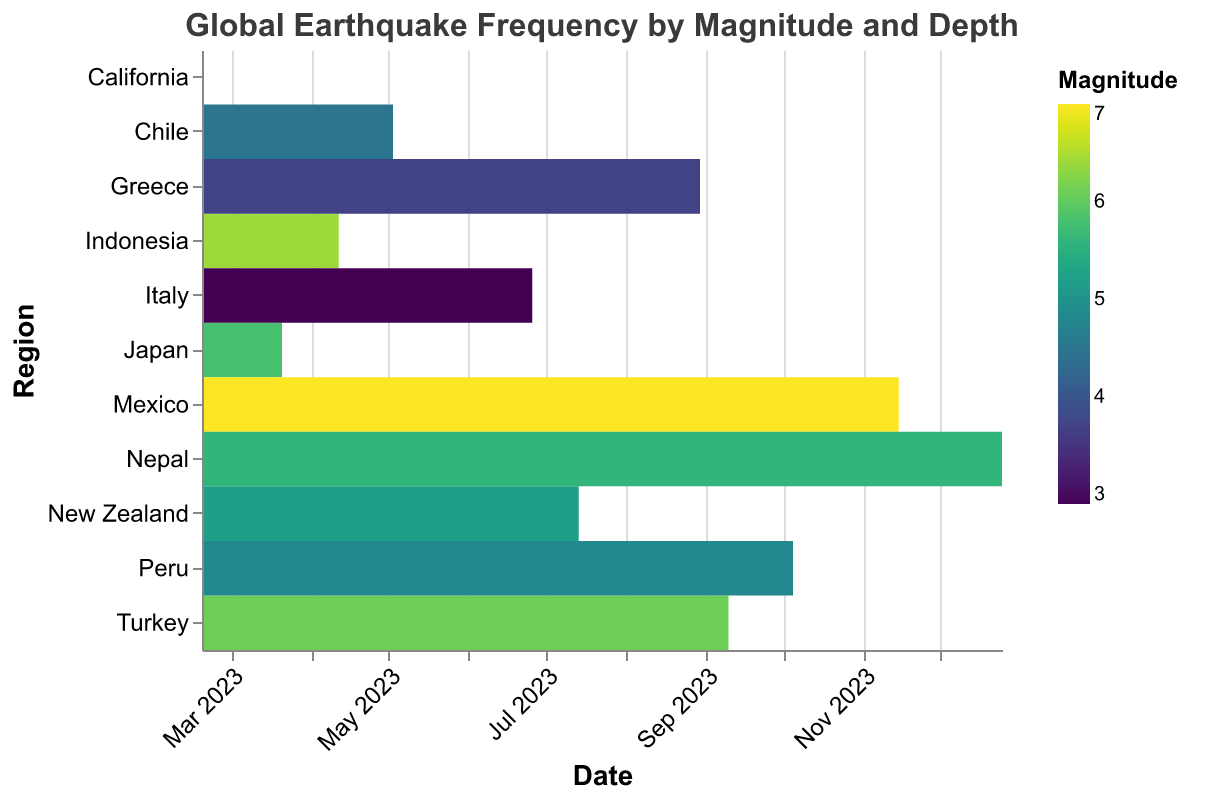What is the title of the heatmap? The title of the heatmap is displayed at the top center of the figure.
Answer: Global Earthquake Frequency by Magnitude and Depth Which region experienced the earthquake with the highest magnitude? The highest magnitude is indicated by the darkest color on the color scale. By looking at the darkest colored rectangle, we can see it is associated with Mexico.
Answer: Mexico How many earthquakes happened in Greece according to the heatmap? Each row represents a region, and each unique color rectangle in that row represents an earthquake event. For Greece, there is only one such rectangle.
Answer: 1 What is the magnitude of the earthquake that occurred in Peru? Hovering over or looking closely at the color legend, we can find the corresponding color to the earthquake that occurred in Peru.
Answer: 4.8 Which earthquake had the greatest depth? The size of the rectangles represents the depth. The largest rectangle corresponds to the earthquake in Indonesia.
Answer: Indonesia Compare the earthquake magnitudes of Japan and Turkey. Which one is greater? By looking at the respective colors for Japan and Turkey and comparing them against the color scale, we see that Turkey's earthquake magnitude (6.1) is greater than Japan's (5.8).
Answer: Turkey How many regions experienced earthquakes with magnitudes between 5.0 and 6.0? By referring to the color legend, we identify earthquakes with magnitudes in this range and count the number of unique region rows they occur in, which are Japan, New Zealand, and Nepal.
Answer: 3 What is the depth of the earthquake in New Zealand? The size of the rectangle associated with New Zealand and the corresponding depth in the tooltip indicates it.
Answer: 48.3 km Which earthquake has a shallower depth: Chile or Peru? Comparing the sizes of the rectangles associated with each region, we find that the Chile earthquake is smaller, indicating a shallower depth.
Answer: Chile What is the average depth of the earthquakes labeled on the heatmap? To find the average, sum the depths and divide by the number of earthquakes. The depths are 10.5 + 32.1 + 70.3 + 15.2 + 5.4 + 48.3 + 11.9 + 55.8 + 20.7 + 60.2 + 41.5. The sum is 372.9, dividing by 11 gives us 33.9 km average depth.
Answer: 33.9 km 